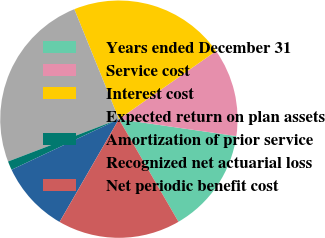<chart> <loc_0><loc_0><loc_500><loc_500><pie_chart><fcel>Years ended December 31<fcel>Service cost<fcel>Interest cost<fcel>Expected return on plan assets<fcel>Amortization of prior service<fcel>Recognized net actuarial loss<fcel>Net periodic benefit cost<nl><fcel>14.35%<fcel>12.01%<fcel>21.4%<fcel>24.68%<fcel>1.2%<fcel>9.66%<fcel>16.7%<nl></chart> 